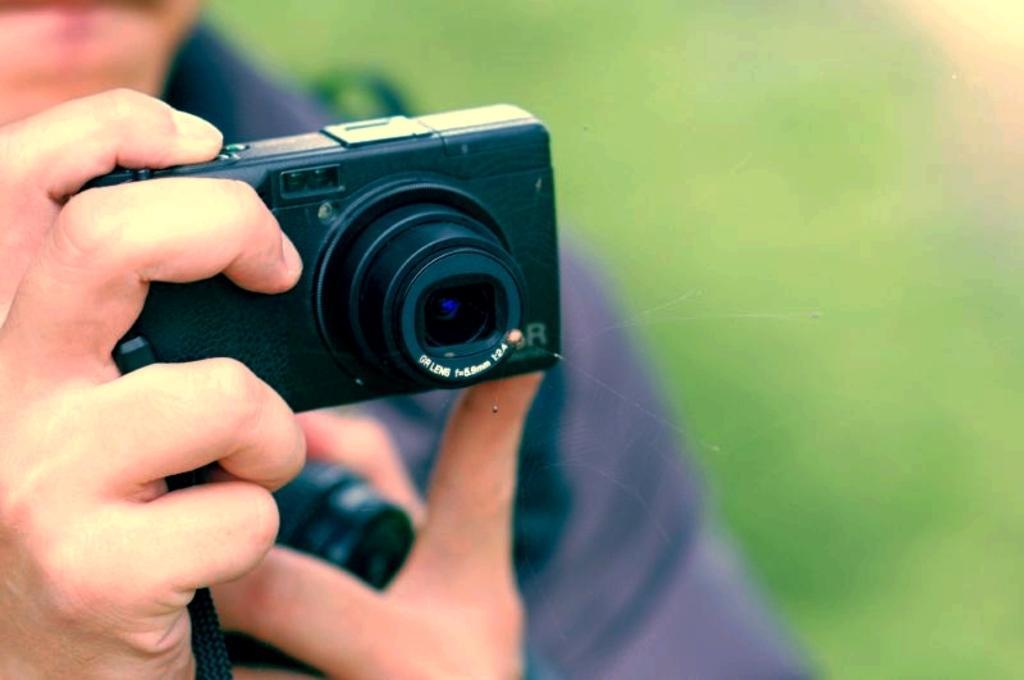How would you summarize this image in a sentence or two? In this image one man is holding a camera. The background is blurry. 